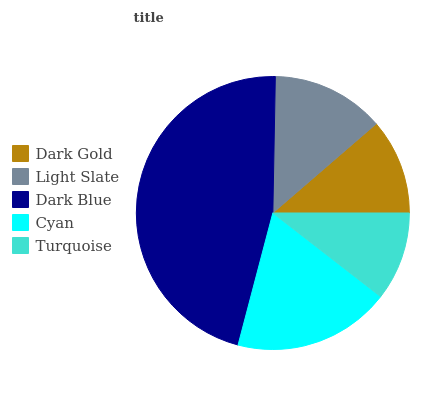Is Turquoise the minimum?
Answer yes or no. Yes. Is Dark Blue the maximum?
Answer yes or no. Yes. Is Light Slate the minimum?
Answer yes or no. No. Is Light Slate the maximum?
Answer yes or no. No. Is Light Slate greater than Dark Gold?
Answer yes or no. Yes. Is Dark Gold less than Light Slate?
Answer yes or no. Yes. Is Dark Gold greater than Light Slate?
Answer yes or no. No. Is Light Slate less than Dark Gold?
Answer yes or no. No. Is Light Slate the high median?
Answer yes or no. Yes. Is Light Slate the low median?
Answer yes or no. Yes. Is Dark Gold the high median?
Answer yes or no. No. Is Cyan the low median?
Answer yes or no. No. 